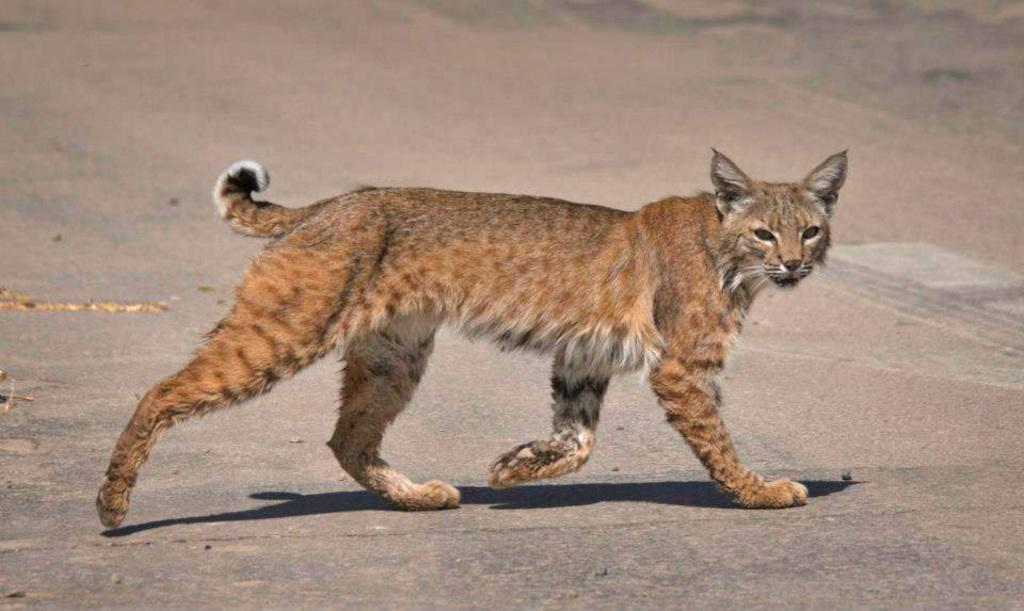What is the main subject in the center of the image? There is a cat in the center of the image. What can be seen at the bottom of the image? There is a road at the bottom of the image. What type of rhythm can be heard coming from the cat in the image? There is no indication of any sound or rhythm in the image, as it features a cat and a road. 